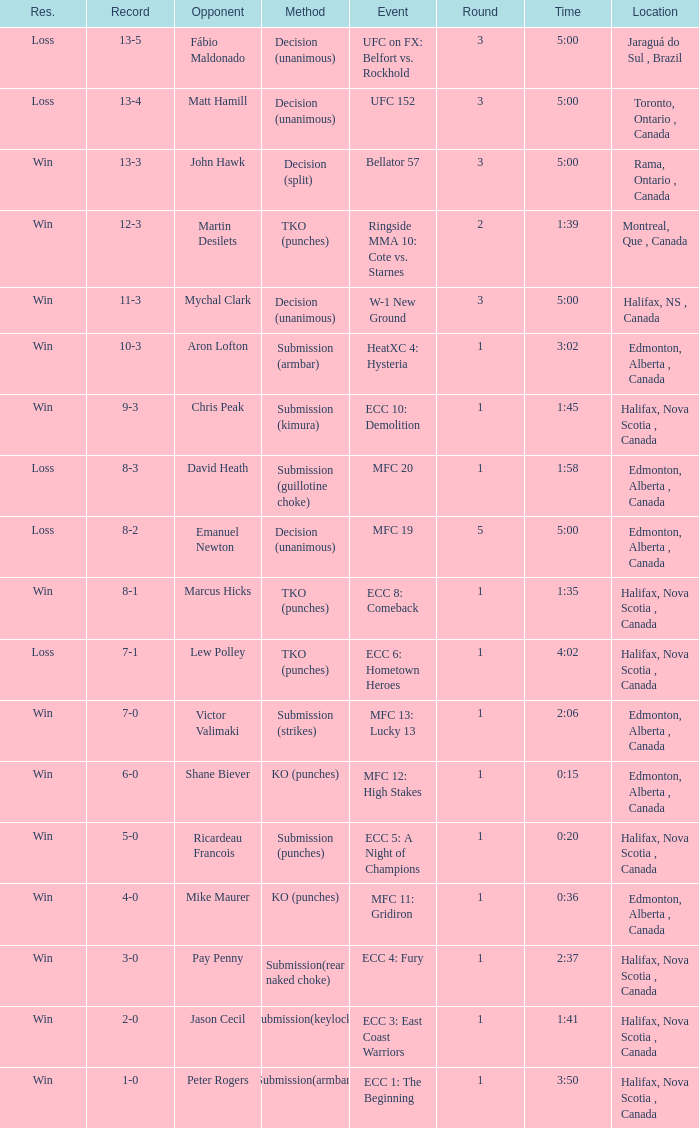What is the location of the match with an event of ecc 8: comeback? Halifax, Nova Scotia , Canada. 